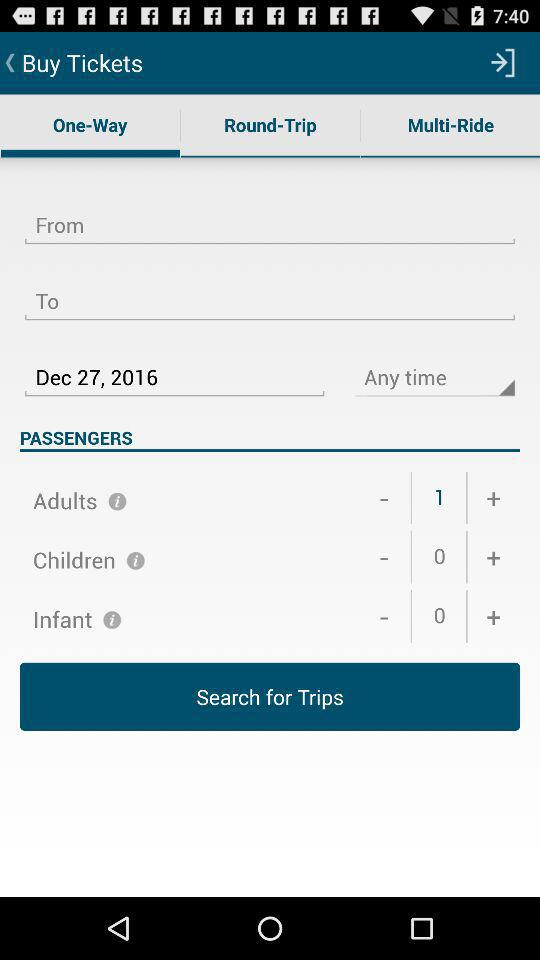What is the number of adults? The number of adults is 1. 